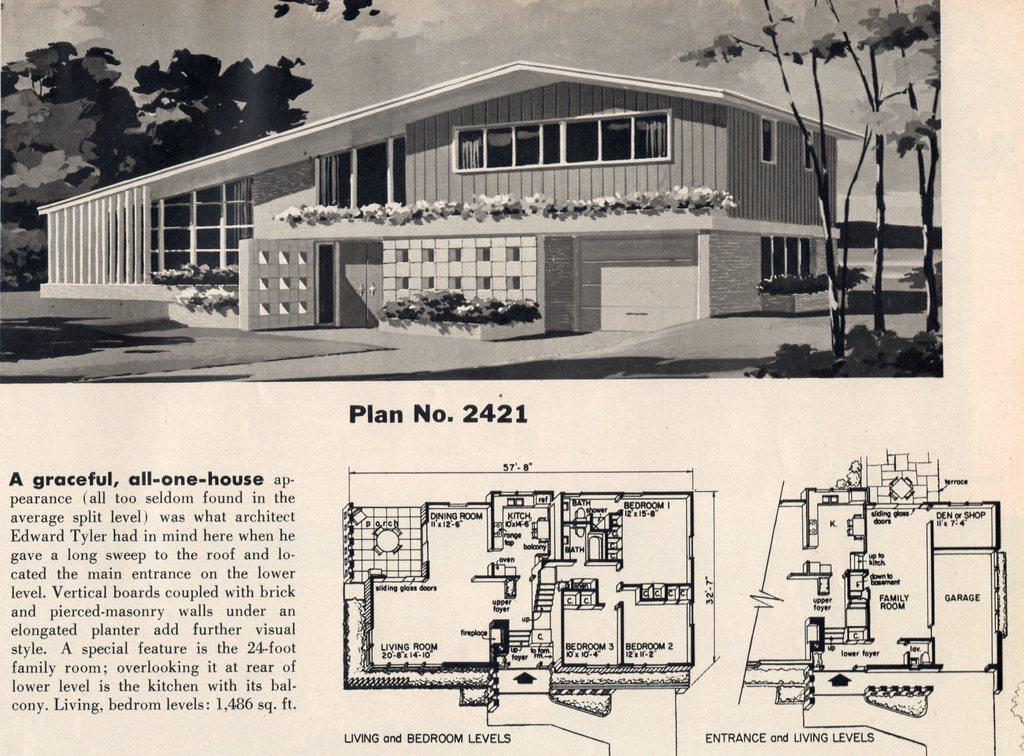What type of visual representation is the image? The image is a poster. What structure can be seen in the image? There is a building in the image. What type of vegetation is present in the image? There are plants and trees in the image. What can be seen in the background of the image? The sky is visible in the background of the image. What additional elements are featured on the poster? There is text and a drawing on the image. How many shelves are visible in the image? There are no shelves present in the image. What type of design is featured on the expansion in the image? There is no expansion or design related to an expansion present in the image. 